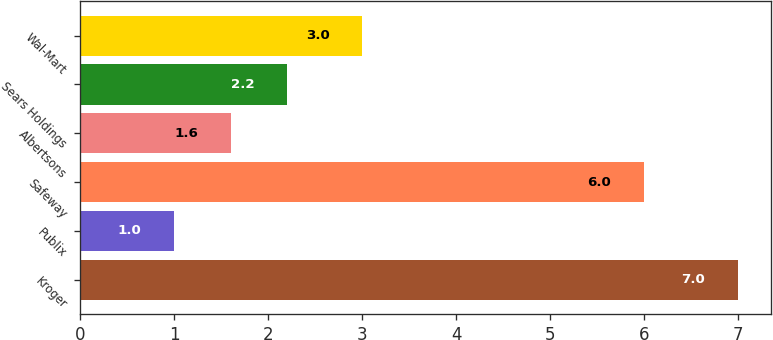Convert chart. <chart><loc_0><loc_0><loc_500><loc_500><bar_chart><fcel>Kroger<fcel>Publix<fcel>Safeway<fcel>Albertsons<fcel>Sears Holdings<fcel>Wal-Mart<nl><fcel>7<fcel>1<fcel>6<fcel>1.6<fcel>2.2<fcel>3<nl></chart> 